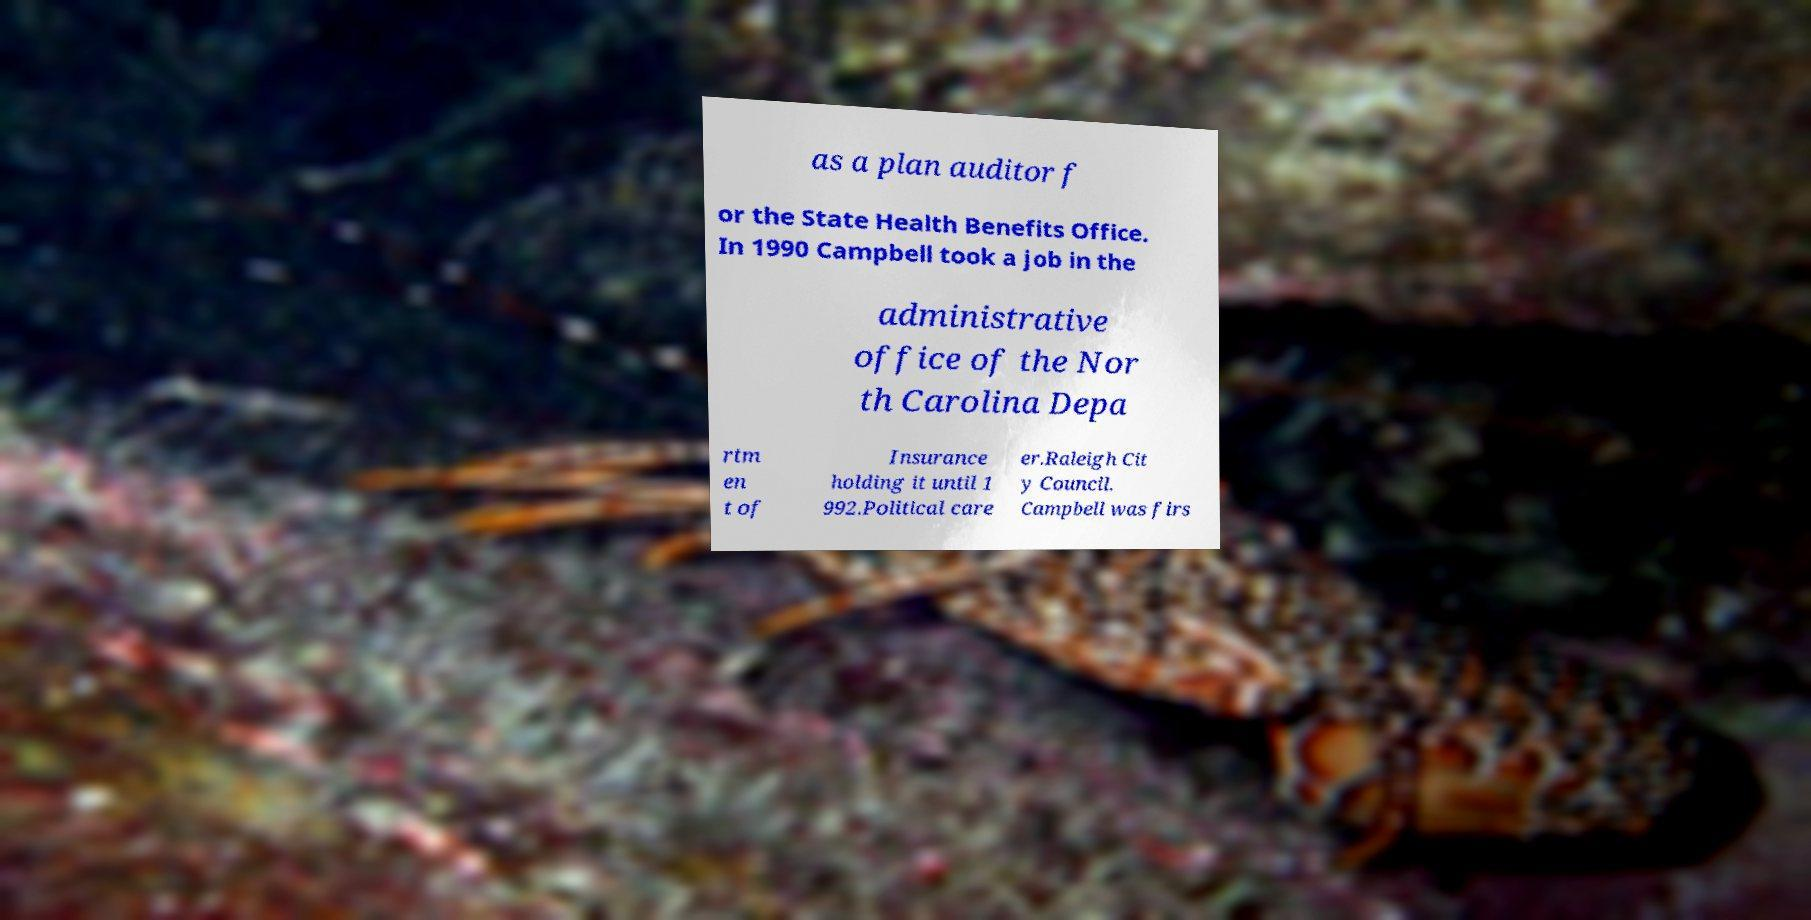What messages or text are displayed in this image? I need them in a readable, typed format. as a plan auditor f or the State Health Benefits Office. In 1990 Campbell took a job in the administrative office of the Nor th Carolina Depa rtm en t of Insurance holding it until 1 992.Political care er.Raleigh Cit y Council. Campbell was firs 